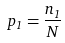Convert formula to latex. <formula><loc_0><loc_0><loc_500><loc_500>p _ { 1 } = \frac { n _ { 1 } } { N }</formula> 